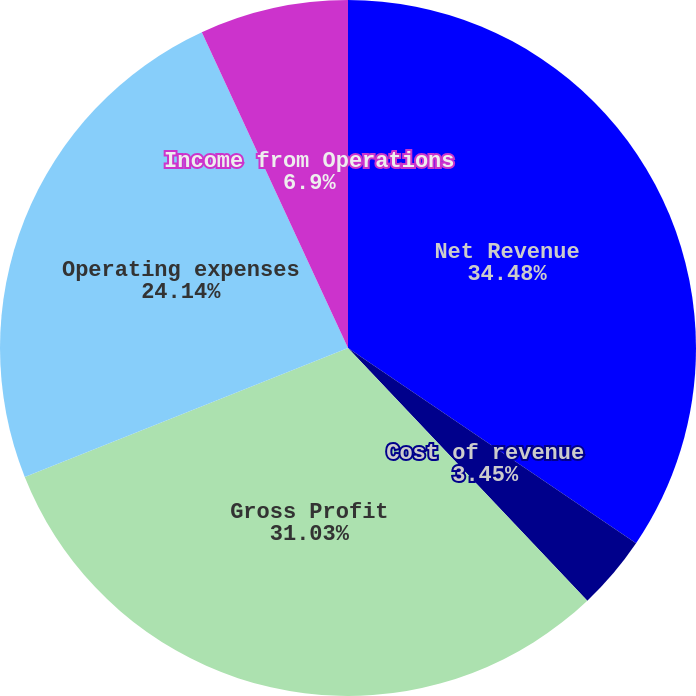Convert chart to OTSL. <chart><loc_0><loc_0><loc_500><loc_500><pie_chart><fcel>Net Revenue<fcel>Cost of revenue<fcel>Gross Profit<fcel>Operating expenses<fcel>Income from Operations<nl><fcel>34.48%<fcel>3.45%<fcel>31.03%<fcel>24.14%<fcel>6.9%<nl></chart> 